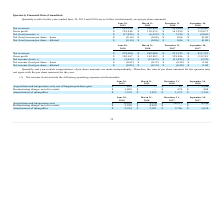According to Extreme Networks's financial document, What was the net revenues in September 30, 2018? According to the financial document, 239,886 (in thousands). The relevant text states: "Net revenues $ 252,359 $ 250,864 $ 252,680 $ 239,886..." Also, What was the gross profit in June 30, 2019? According to the financial document, 138,946 (in thousands). The relevant text states: "Gross profit $ 138,946 $ 138,919 $ 141,299 $ 132,071..." Also, What was the basic net (loss) income per share in December 31, 2018? According to the financial document, 0.06. The relevant text states: "Net (loss) income per share – basic $ (0.14) $ (0.06) $ 0.06 $ (0.08)..." Also, can you calculate: What was the change in the net revenues between March 31 and June 30, 2019? Based on the calculation: 252,359-250,864, the result is 1495 (in thousands). This is based on the information: "Net revenues $ 252,359 $ 250,864 $ 252,680 $ 239,886 Net revenues $ 252,359 $ 250,864 $ 252,680 $ 239,886..." The key data points involved are: 250,864, 252,359. Also, can you calculate: What was the change in the gross profit between September 30 and December 31, 2018? Based on the calculation: 141,299-132,071, the result is 9228 (in thousands). This is based on the information: "Gross profit $ 138,946 $ 138,919 $ 141,299 $ 132,071 Gross profit $ 138,946 $ 138,919 $ 141,299 $ 132,071..." The key data points involved are: 132,071, 141,299. Also, can you calculate: What was the percentage change in the net (loss) income between March 31 and June 30, 2019? To answer this question, I need to perform calculations using the financial data. The calculation is: (-17,055+6,932)/-6,932, which equals 146.03 (percentage). This is based on the information: "Net (loss) income (1) $ (17,055) $ (6,932) $ 7,199 $ (9,065) Net (loss) income (1) $ (17,055) $ (6,932) $ 7,199 $ (9,065)..." The key data points involved are: 17,055, 6,932. 